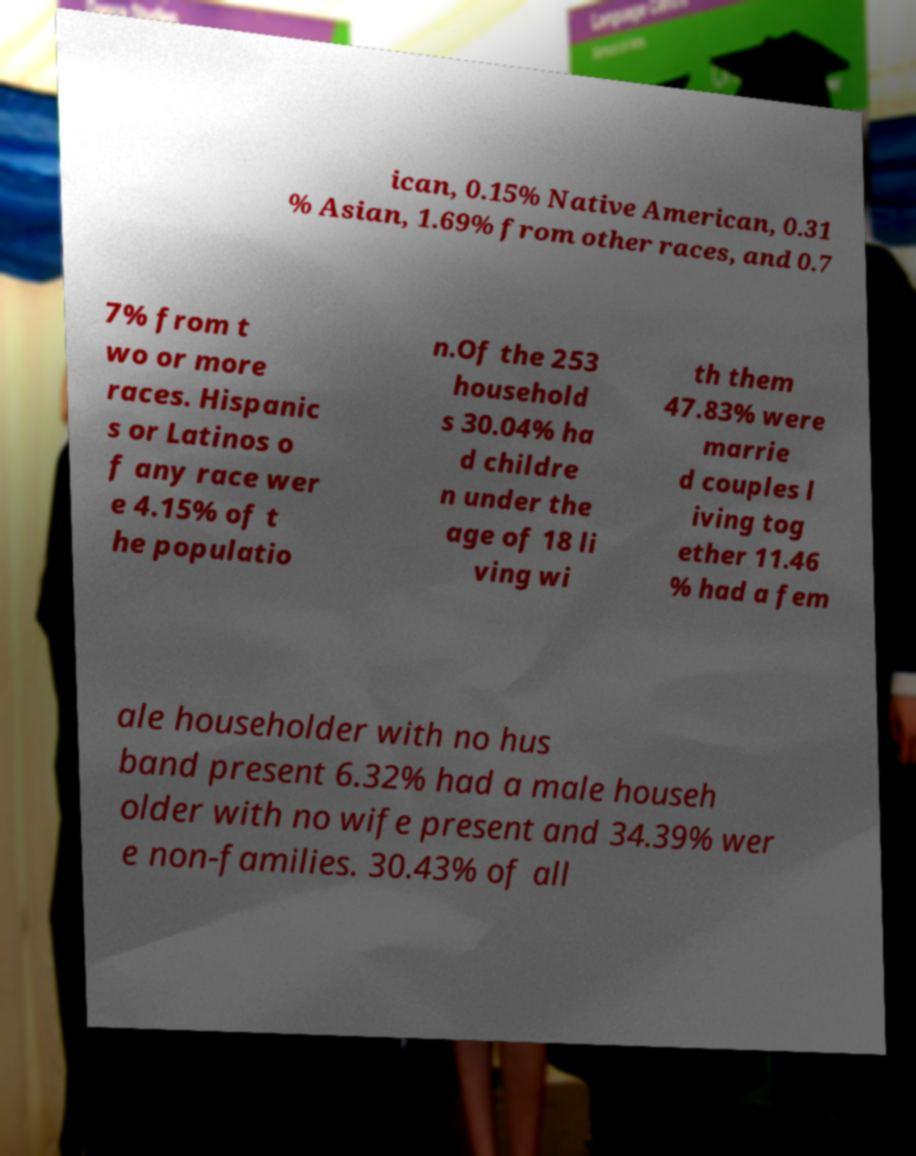Could you extract and type out the text from this image? ican, 0.15% Native American, 0.31 % Asian, 1.69% from other races, and 0.7 7% from t wo or more races. Hispanic s or Latinos o f any race wer e 4.15% of t he populatio n.Of the 253 household s 30.04% ha d childre n under the age of 18 li ving wi th them 47.83% were marrie d couples l iving tog ether 11.46 % had a fem ale householder with no hus band present 6.32% had a male househ older with no wife present and 34.39% wer e non-families. 30.43% of all 